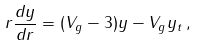<formula> <loc_0><loc_0><loc_500><loc_500>r \frac { d y } { d r } = ( V _ { g } - 3 ) y - V _ { g } y _ { t } \, ,</formula> 